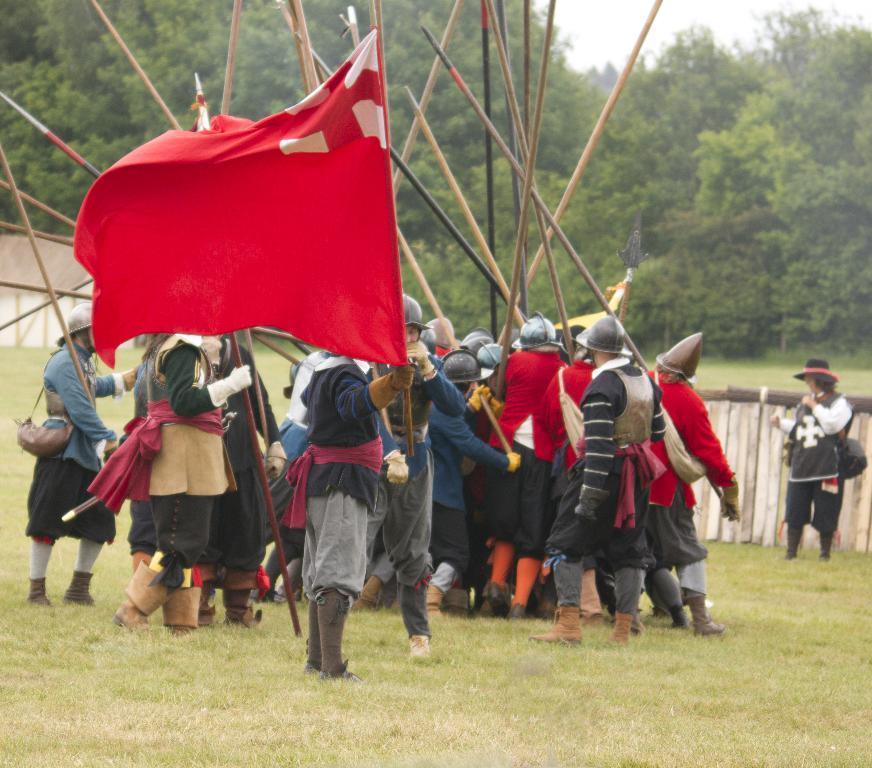Could you give a brief overview of what you see in this image? There is a group of persons standing and holding some sticks. The person standing in middle is holding a flag. There is a fencing on the right side of this image. There are some trees in the background. 